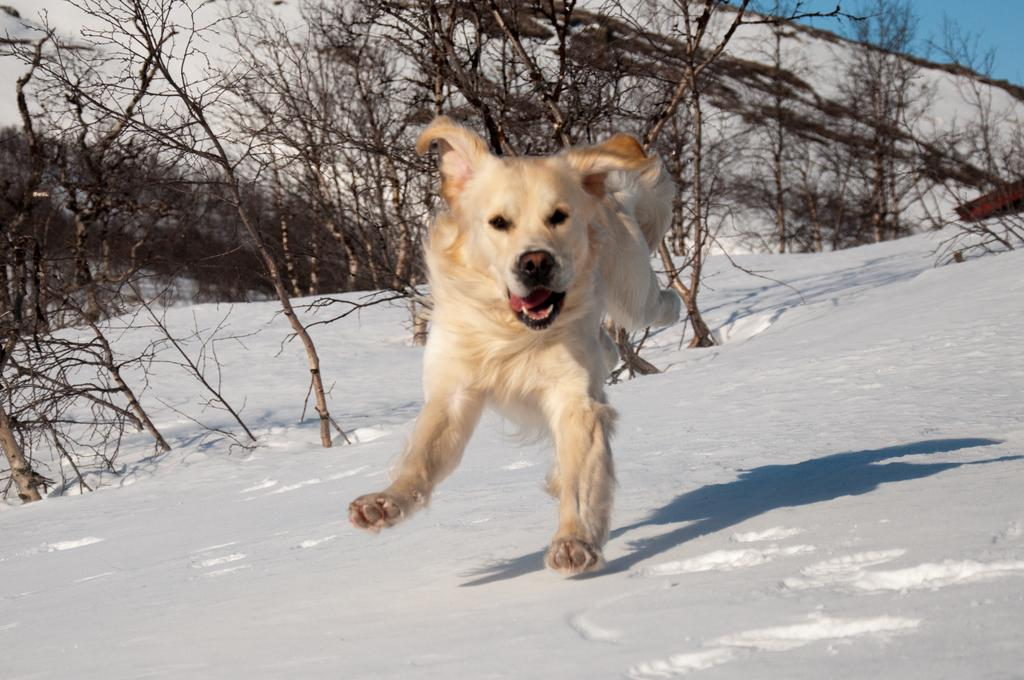What type of animal can be seen in the image? There is an animal in the image, but its specific type cannot be determined from the provided facts. What is the weather like in the image? There is snow visible in the image, which suggests a cold and wintry environment. What geographical feature is present in the image? There is a hill in the image. What type of vegetation is present in the image? Dried trees are present in the image. What is visible in the sky in the image? The sky is visible in the image. What type of ornament is hanging from the dried trees in the image? There is no ornament hanging from the dried trees in the image; only the trees themselves are present. What type of feast is being prepared in the image? There is no indication of a feast or any food preparation in the image. 